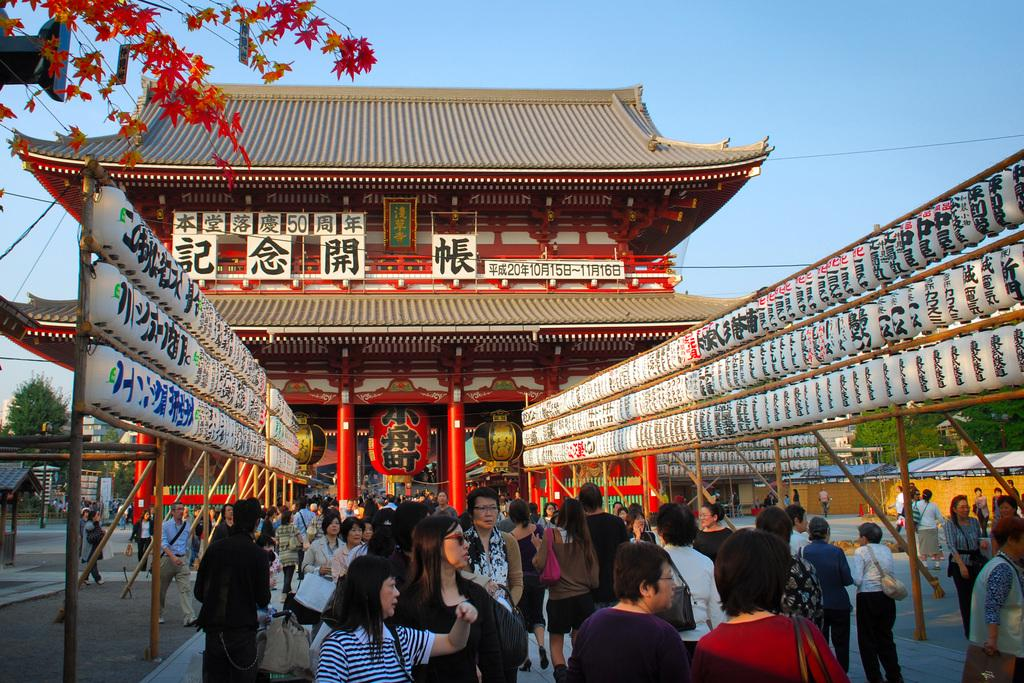What are the people in the image doing? The people in the image are walking. What can be seen in the background of the image? There is a house and trees in the background of the image. What type of baseball position can be seen in the image? There is no baseball or any positions related to it present in the image. 